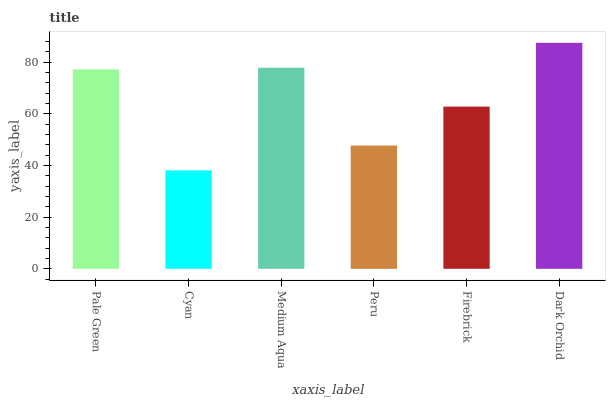Is Cyan the minimum?
Answer yes or no. Yes. Is Dark Orchid the maximum?
Answer yes or no. Yes. Is Medium Aqua the minimum?
Answer yes or no. No. Is Medium Aqua the maximum?
Answer yes or no. No. Is Medium Aqua greater than Cyan?
Answer yes or no. Yes. Is Cyan less than Medium Aqua?
Answer yes or no. Yes. Is Cyan greater than Medium Aqua?
Answer yes or no. No. Is Medium Aqua less than Cyan?
Answer yes or no. No. Is Pale Green the high median?
Answer yes or no. Yes. Is Firebrick the low median?
Answer yes or no. Yes. Is Medium Aqua the high median?
Answer yes or no. No. Is Dark Orchid the low median?
Answer yes or no. No. 